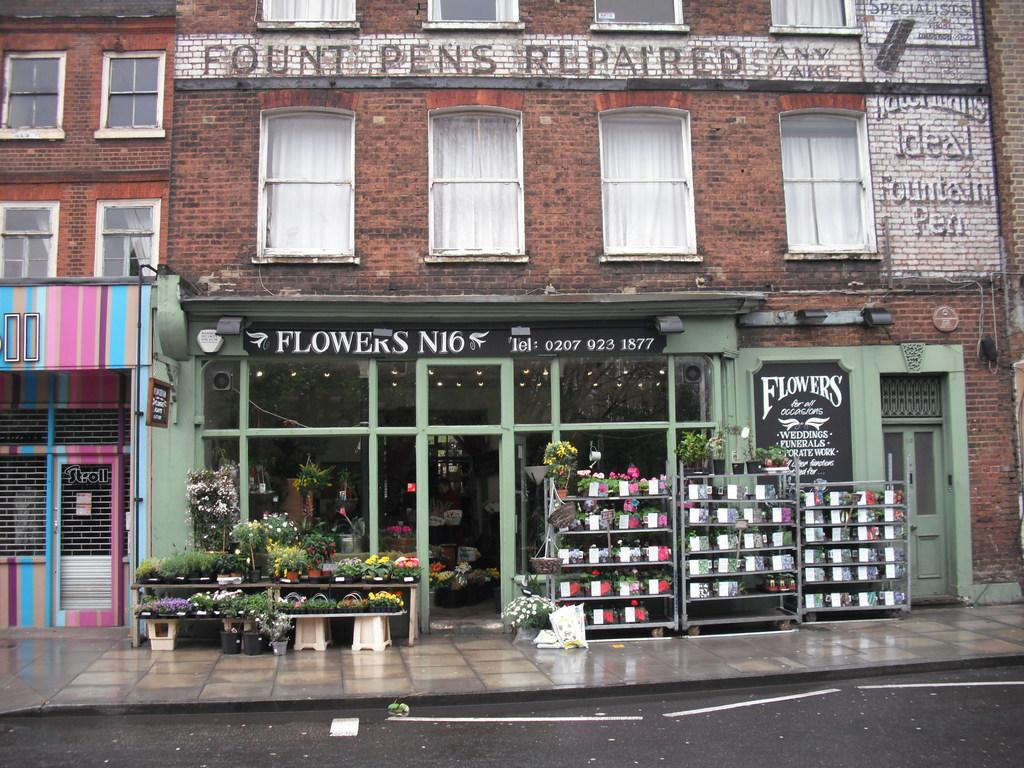Provide a one-sentence caption for the provided image. Pots of flowers are outside the Flowers N16 storefront. 